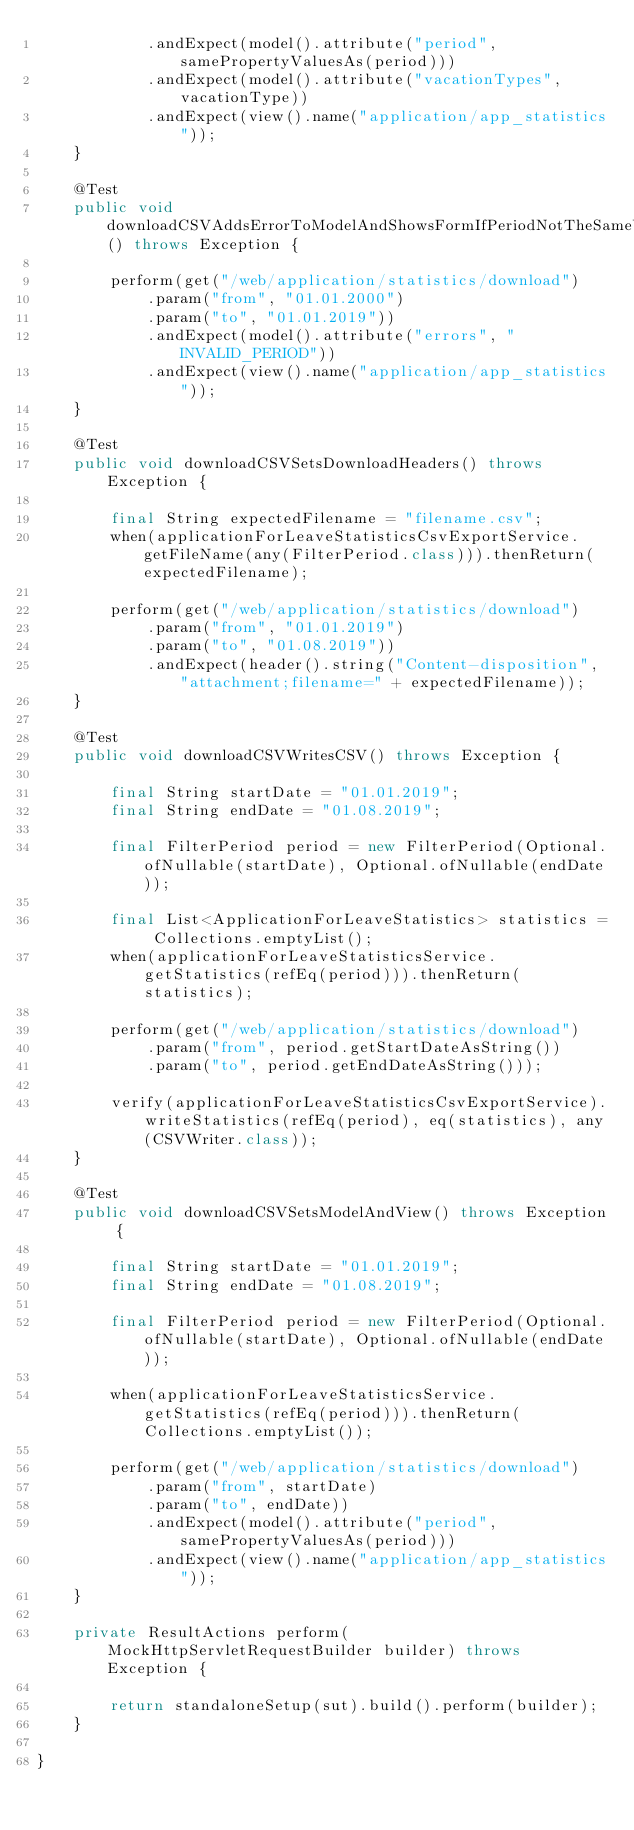<code> <loc_0><loc_0><loc_500><loc_500><_Java_>            .andExpect(model().attribute("period", samePropertyValuesAs(period)))
            .andExpect(model().attribute("vacationTypes", vacationType))
            .andExpect(view().name("application/app_statistics"));
    }

    @Test
    public void downloadCSVAddsErrorToModelAndShowsFormIfPeriodNotTheSameYear() throws Exception {

        perform(get("/web/application/statistics/download")
            .param("from", "01.01.2000")
            .param("to", "01.01.2019"))
            .andExpect(model().attribute("errors", "INVALID_PERIOD"))
            .andExpect(view().name("application/app_statistics"));
    }

    @Test
    public void downloadCSVSetsDownloadHeaders() throws Exception {

        final String expectedFilename = "filename.csv";
        when(applicationForLeaveStatisticsCsvExportService.getFileName(any(FilterPeriod.class))).thenReturn(expectedFilename);

        perform(get("/web/application/statistics/download")
            .param("from", "01.01.2019")
            .param("to", "01.08.2019"))
            .andExpect(header().string("Content-disposition", "attachment;filename=" + expectedFilename));
    }

    @Test
    public void downloadCSVWritesCSV() throws Exception {

        final String startDate = "01.01.2019";
        final String endDate = "01.08.2019";

        final FilterPeriod period = new FilterPeriod(Optional.ofNullable(startDate), Optional.ofNullable(endDate));

        final List<ApplicationForLeaveStatistics> statistics = Collections.emptyList();
        when(applicationForLeaveStatisticsService.getStatistics(refEq(period))).thenReturn(statistics);

        perform(get("/web/application/statistics/download")
            .param("from", period.getStartDateAsString())
            .param("to", period.getEndDateAsString()));

        verify(applicationForLeaveStatisticsCsvExportService).writeStatistics(refEq(period), eq(statistics), any(CSVWriter.class));
    }

    @Test
    public void downloadCSVSetsModelAndView() throws Exception {

        final String startDate = "01.01.2019";
        final String endDate = "01.08.2019";

        final FilterPeriod period = new FilterPeriod(Optional.ofNullable(startDate), Optional.ofNullable(endDate));

        when(applicationForLeaveStatisticsService.getStatistics(refEq(period))).thenReturn( Collections.emptyList());

        perform(get("/web/application/statistics/download")
            .param("from", startDate)
            .param("to", endDate))
            .andExpect(model().attribute("period", samePropertyValuesAs(period)))
            .andExpect(view().name("application/app_statistics"));
    }

    private ResultActions perform(MockHttpServletRequestBuilder builder) throws Exception {

        return standaloneSetup(sut).build().perform(builder);
    }

}
</code> 